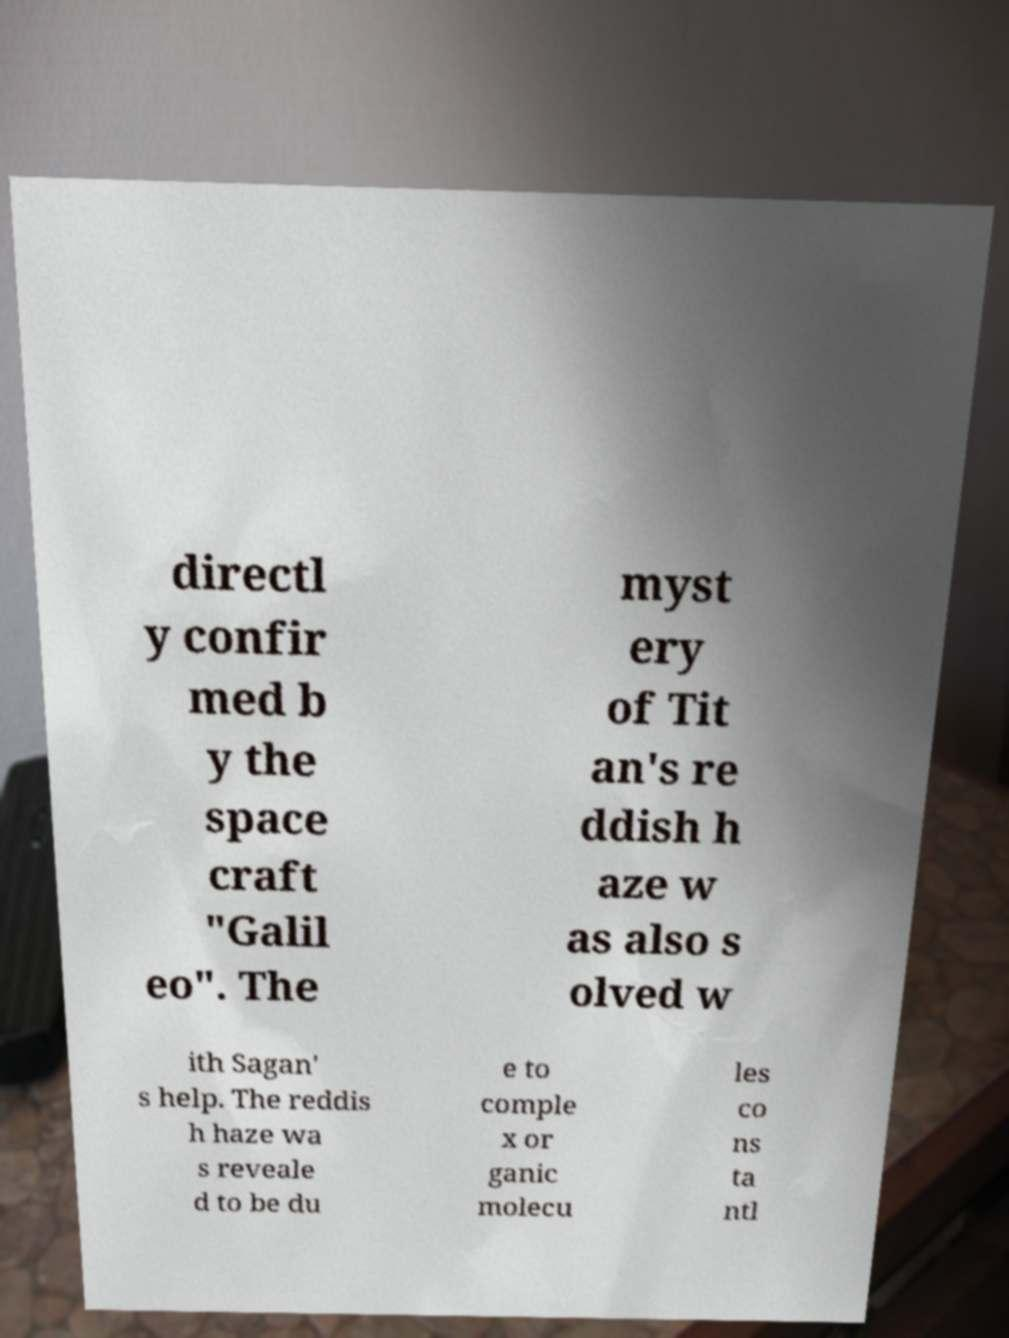Please identify and transcribe the text found in this image. directl y confir med b y the space craft "Galil eo". The myst ery of Tit an's re ddish h aze w as also s olved w ith Sagan' s help. The reddis h haze wa s reveale d to be du e to comple x or ganic molecu les co ns ta ntl 